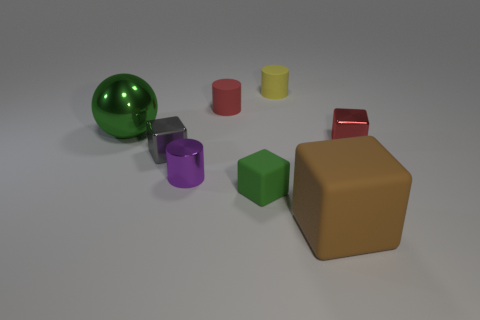What number of other things are the same material as the tiny green object?
Keep it short and to the point. 3. Is the material of the small red object to the right of the green matte thing the same as the large thing that is behind the big brown object?
Offer a very short reply. Yes. How many things are to the right of the yellow cylinder and behind the large rubber cube?
Provide a succinct answer. 1. Are there any tiny green objects of the same shape as the brown thing?
Offer a very short reply. Yes. There is a yellow matte thing that is the same size as the green matte thing; what shape is it?
Provide a succinct answer. Cylinder. Are there the same number of tiny objects that are in front of the tiny purple metal cylinder and big rubber cubes that are behind the green matte block?
Offer a terse response. No. There is a green thing on the right side of the cylinder that is in front of the small red block; what is its size?
Keep it short and to the point. Small. Is there a blue metal object that has the same size as the green metal object?
Your answer should be compact. No. What is the color of the large thing that is the same material as the red cube?
Make the answer very short. Green. Are there fewer green shiny objects than small matte things?
Provide a succinct answer. Yes. 